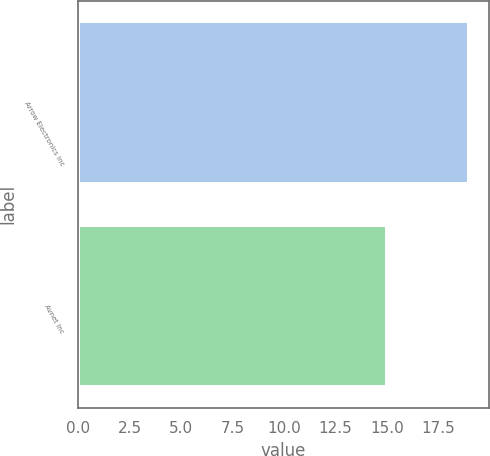Convert chart. <chart><loc_0><loc_0><loc_500><loc_500><bar_chart><fcel>Arrow Electronics Inc<fcel>Avnet Inc<nl><fcel>19<fcel>15<nl></chart> 